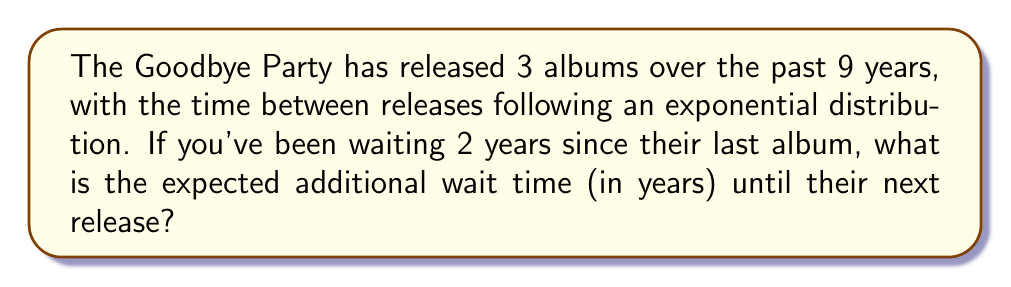What is the answer to this math problem? Let's approach this step-by-step:

1) First, we need to calculate the rate parameter ($\lambda$) of the exponential distribution. Given that there have been 3 albums released over 9 years, we have 2 inter-release intervals. The average interval is:

   $$\text{Average interval} = \frac{9 \text{ years}}{2} = 4.5 \text{ years}$$

2) For an exponential distribution, the rate parameter $\lambda$ is the inverse of the mean. So:

   $$\lambda = \frac{1}{4.5} \approx 0.2222 \text{ per year}$$

3) The exponential distribution has the memoryless property, which means that the expected additional wait time is the same as the overall expected wait time, regardless of how long we've already waited.

4) The expected value (mean) of an exponential distribution is given by $\frac{1}{\lambda}$. We've already calculated this in step 1, but let's state it formally:

   $$E(X) = \frac{1}{\lambda} = 4.5 \text{ years}$$

5) Therefore, regardless of the fact that you've already waited 2 years, the expected additional wait time remains 4.5 years.
Answer: 4.5 years 